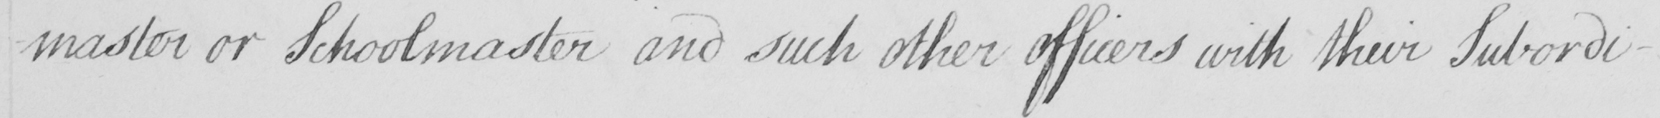Can you tell me what this handwritten text says? -master or Schoolmaster and such other officers with their Subordi- 